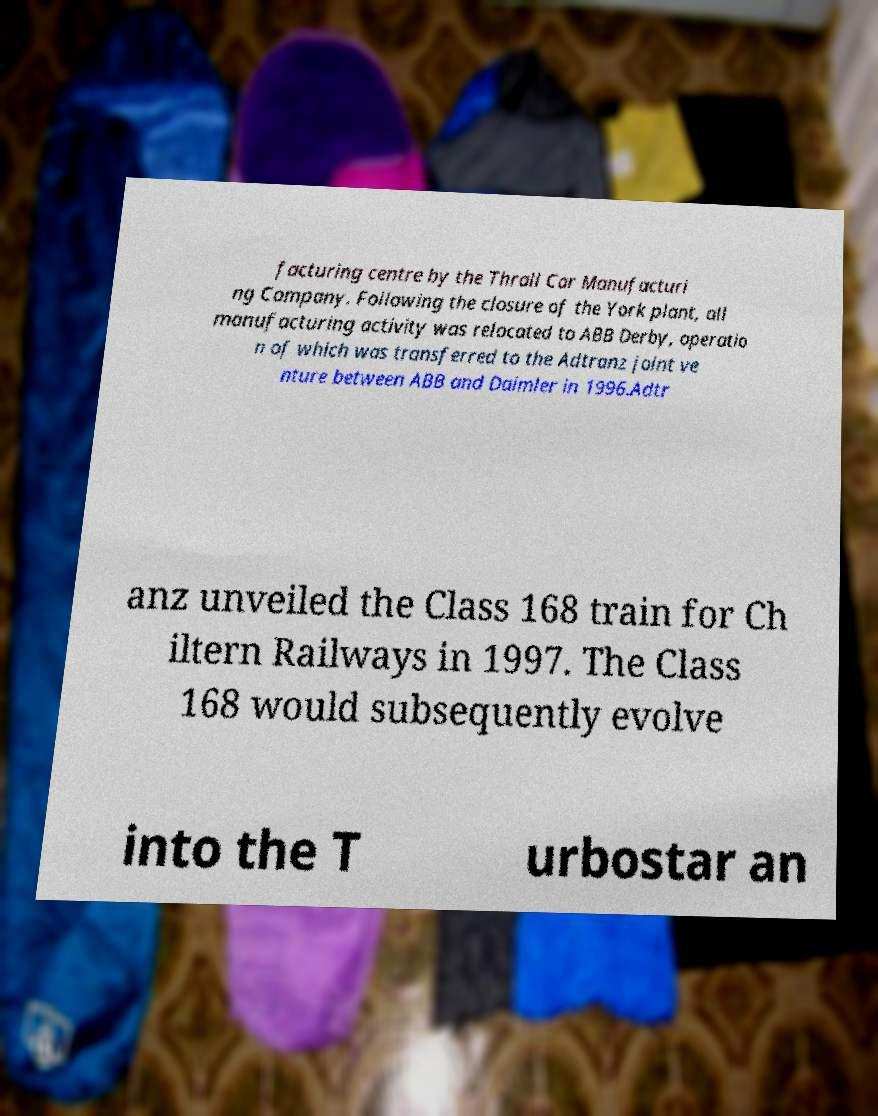There's text embedded in this image that I need extracted. Can you transcribe it verbatim? facturing centre by the Thrall Car Manufacturi ng Company. Following the closure of the York plant, all manufacturing activity was relocated to ABB Derby, operatio n of which was transferred to the Adtranz joint ve nture between ABB and Daimler in 1996.Adtr anz unveiled the Class 168 train for Ch iltern Railways in 1997. The Class 168 would subsequently evolve into the T urbostar an 